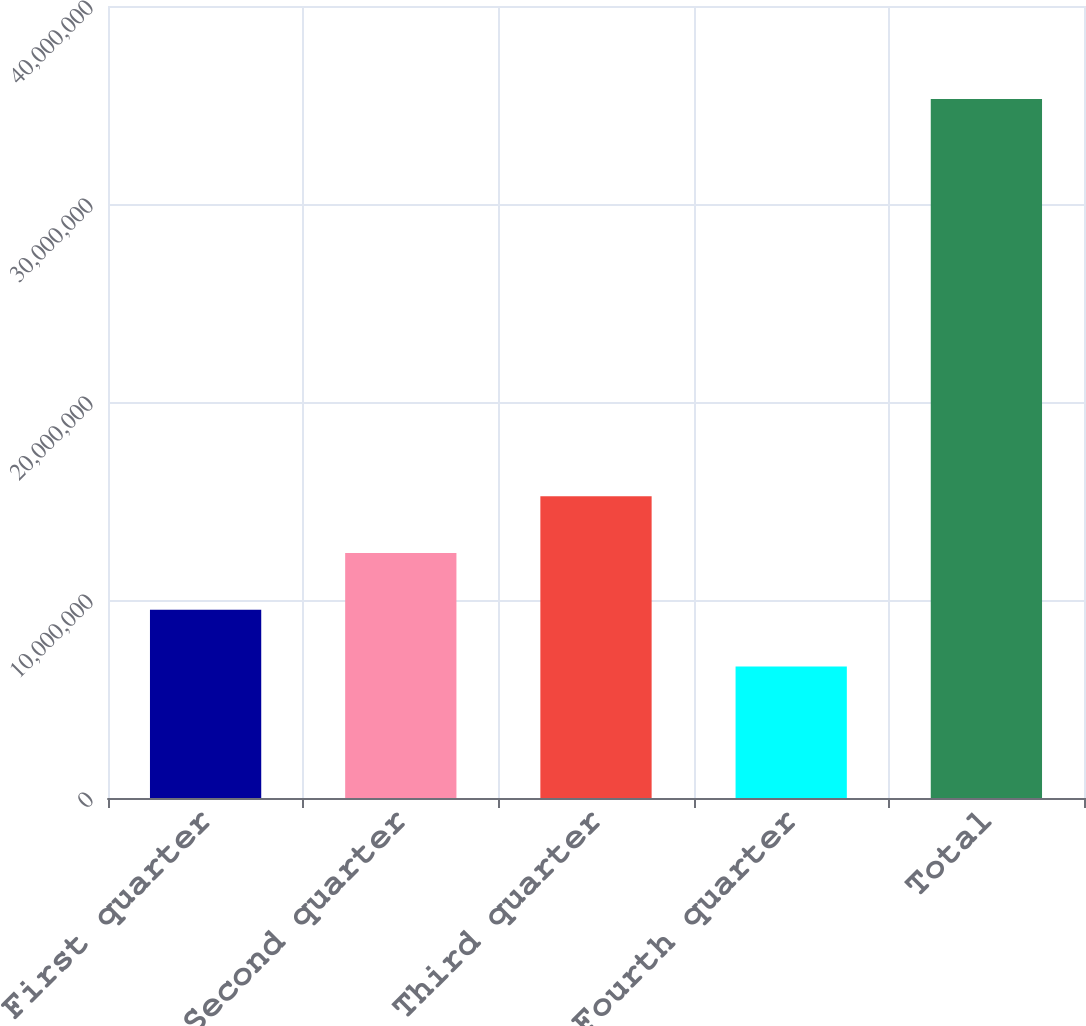Convert chart. <chart><loc_0><loc_0><loc_500><loc_500><bar_chart><fcel>First quarter<fcel>Second quarter<fcel>Third quarter<fcel>Fourth quarter<fcel>Total<nl><fcel>9.51262e+06<fcel>1.23784e+07<fcel>1.52441e+07<fcel>6.6469e+06<fcel>3.53042e+07<nl></chart> 